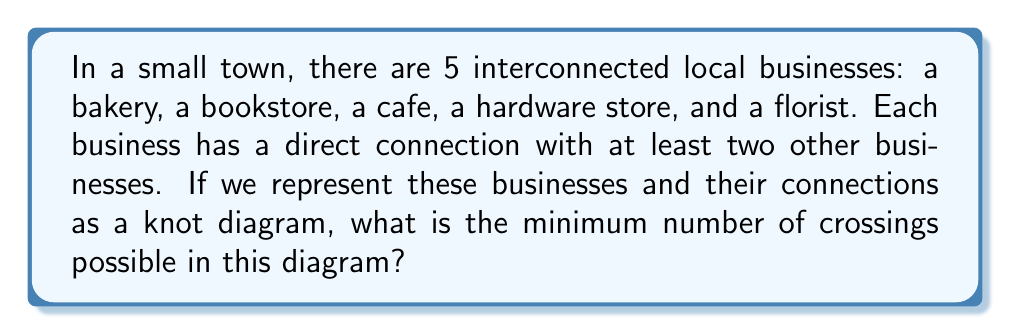Show me your answer to this math problem. To solve this problem, let's follow these steps:

1) First, we need to understand that in knot theory, a knot diagram with 5 crossings is called a cinquefoil knot.

2) The minimum number of crossings for a knot diagram with 5 interconnected components is given by the formula:

   $$ c_{min} = \binom{n}{2} - (n-1) $$

   where $n$ is the number of components (in this case, businesses).

3) In our case, $n = 5$. Let's substitute this into the formula:

   $$ c_{min} = \binom{5}{2} - (5-1) $$

4) Calculate $\binom{5}{2}$:
   $$ \binom{5}{2} = \frac{5!}{2!(5-2)!} = \frac{5 \cdot 4}{2 \cdot 1} = 10 $$

5) Now, we can complete the calculation:
   $$ c_{min} = 10 - (5-1) = 10 - 4 = 6 $$

Therefore, the minimum number of crossings in the knot diagram representing the interconnected local businesses is 6.
Answer: 6 crossings 